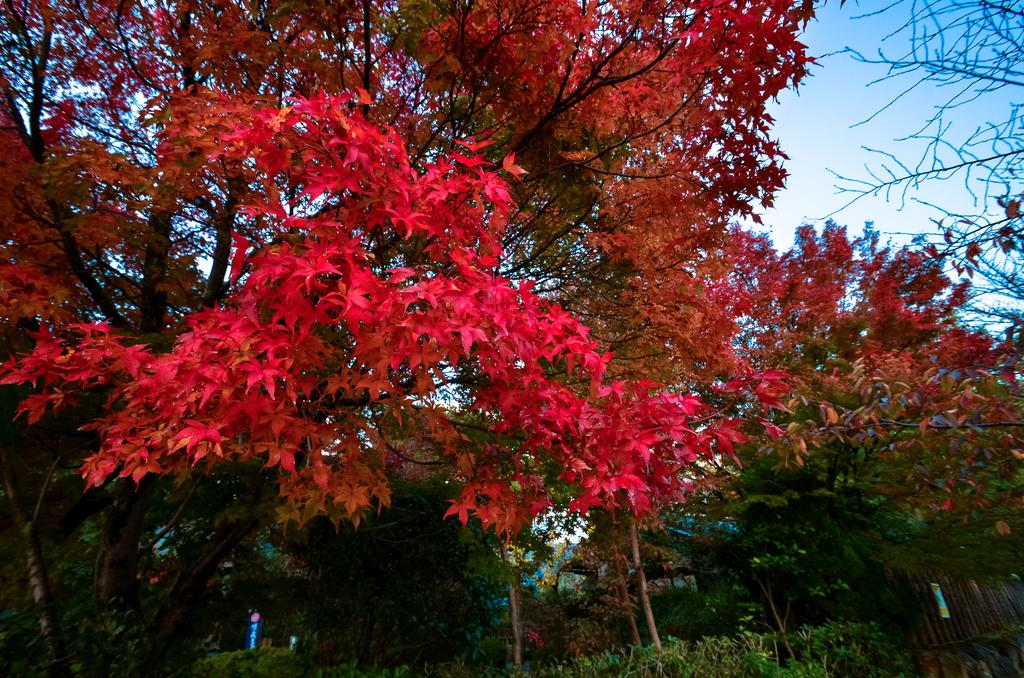What is visible in the center of the image? The sky, plants, and trees are visible in the center of the image. Can you describe the plants and trees in the image? Yes, there are plants and trees in the center of the image. What is the primary color of the sky in the image? The primary color of the sky in the image cannot be determined without more information about the lighting and weather conditions. What type of jeans is the queen wearing in the image? There is no queen or jeans present in the image. 